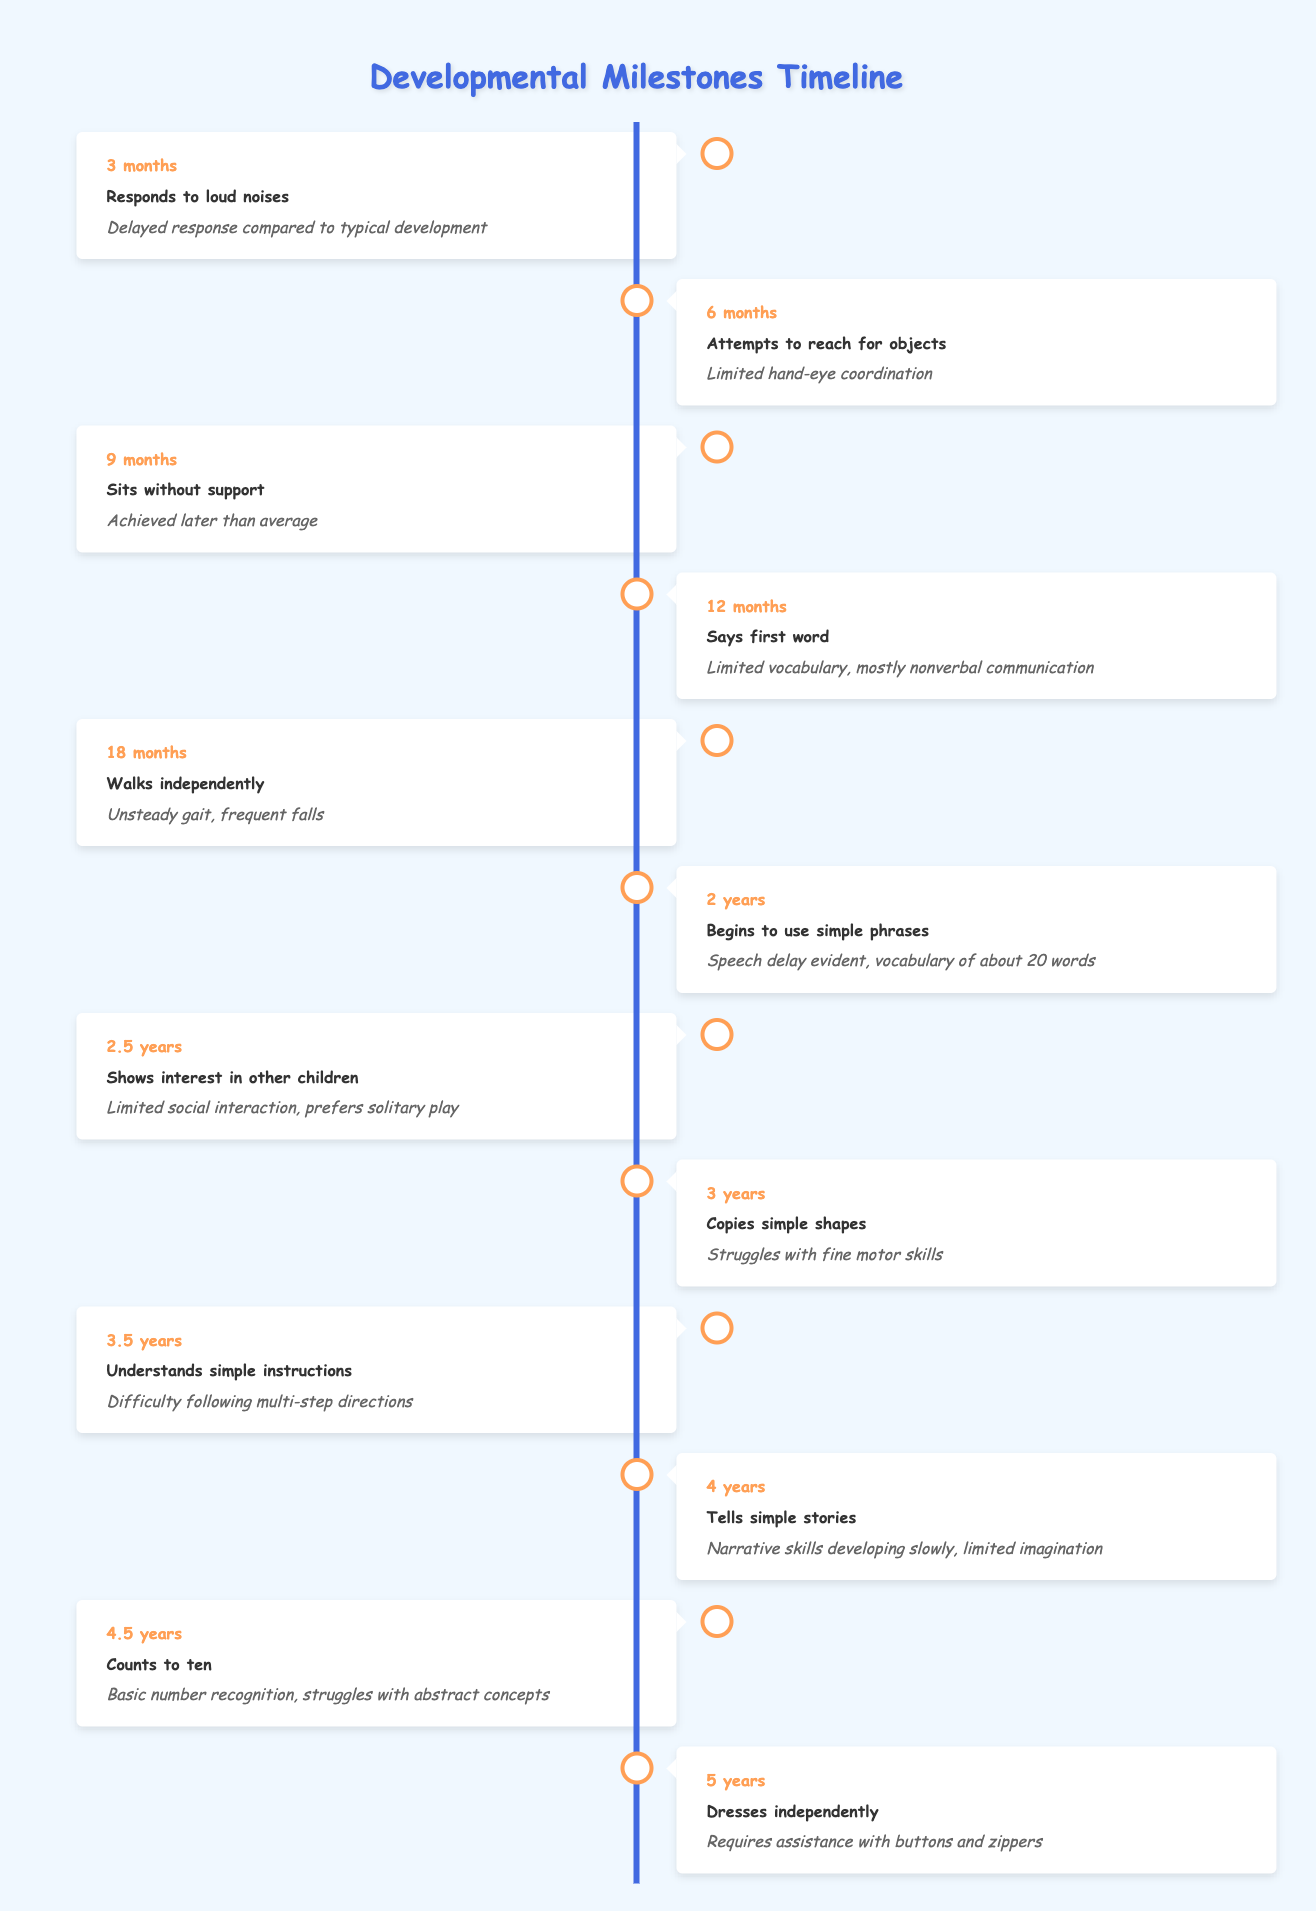What milestone is achieved by the child at 18 months? The table can be checked for the age of 18 months, which shows the milestone "Walks independently."
Answer: Walks independently At what age does the child begin to use simple phrases? The table indicates that the child begins to use simple phrases at 2 years of age.
Answer: 2 years Is the child able to dress independently by the age of 4? By checking the table, the milestone for age 4 shows that the child is still developing narrative skills and isn't mentioned as dressing independently, which is noted at age 5. Therefore, the answer is no.
Answer: No What is the difference in milestones achieved at 3 years compared to 2 years? At 2 years, the child begins to use simple phrases, while at 3 years, the milestone is that the child can copy simple shapes. This indicates a shift from verbal development to fine motor skills, showing progress in different areas of development.
Answer: The child progresses from verbal skills to fine motor skills What milestone noted at age 4 suggests limited imagination? The table states that at age 4, the child "Tells simple stories," and the noted remarks indicate that narrative skills are developing slowly, leading to the conclusion of limited imagination.
Answer: Tells simple stories How many months does it take for the child to walk independently, starting from when they begin to show motor skills? The child walks independently at 18 months and begins to reach for objects at 6 months; thus, the difference is 12 months between attempting to reach objects and walking independently.
Answer: 12 months At what age does the child first respond to loud noises, and how is the response described? According to the table, at 3 months, the child responds to loud noises, but this response is noted as delayed compared to typical development.
Answer: 3 months, delayed response Does the child understand simple instructions by age 3.5? The milestone for 3.5 years indicates that the child understands simple instructions, but with difficulty following multi-step directions, suggesting a partial yes answer.
Answer: Yes 